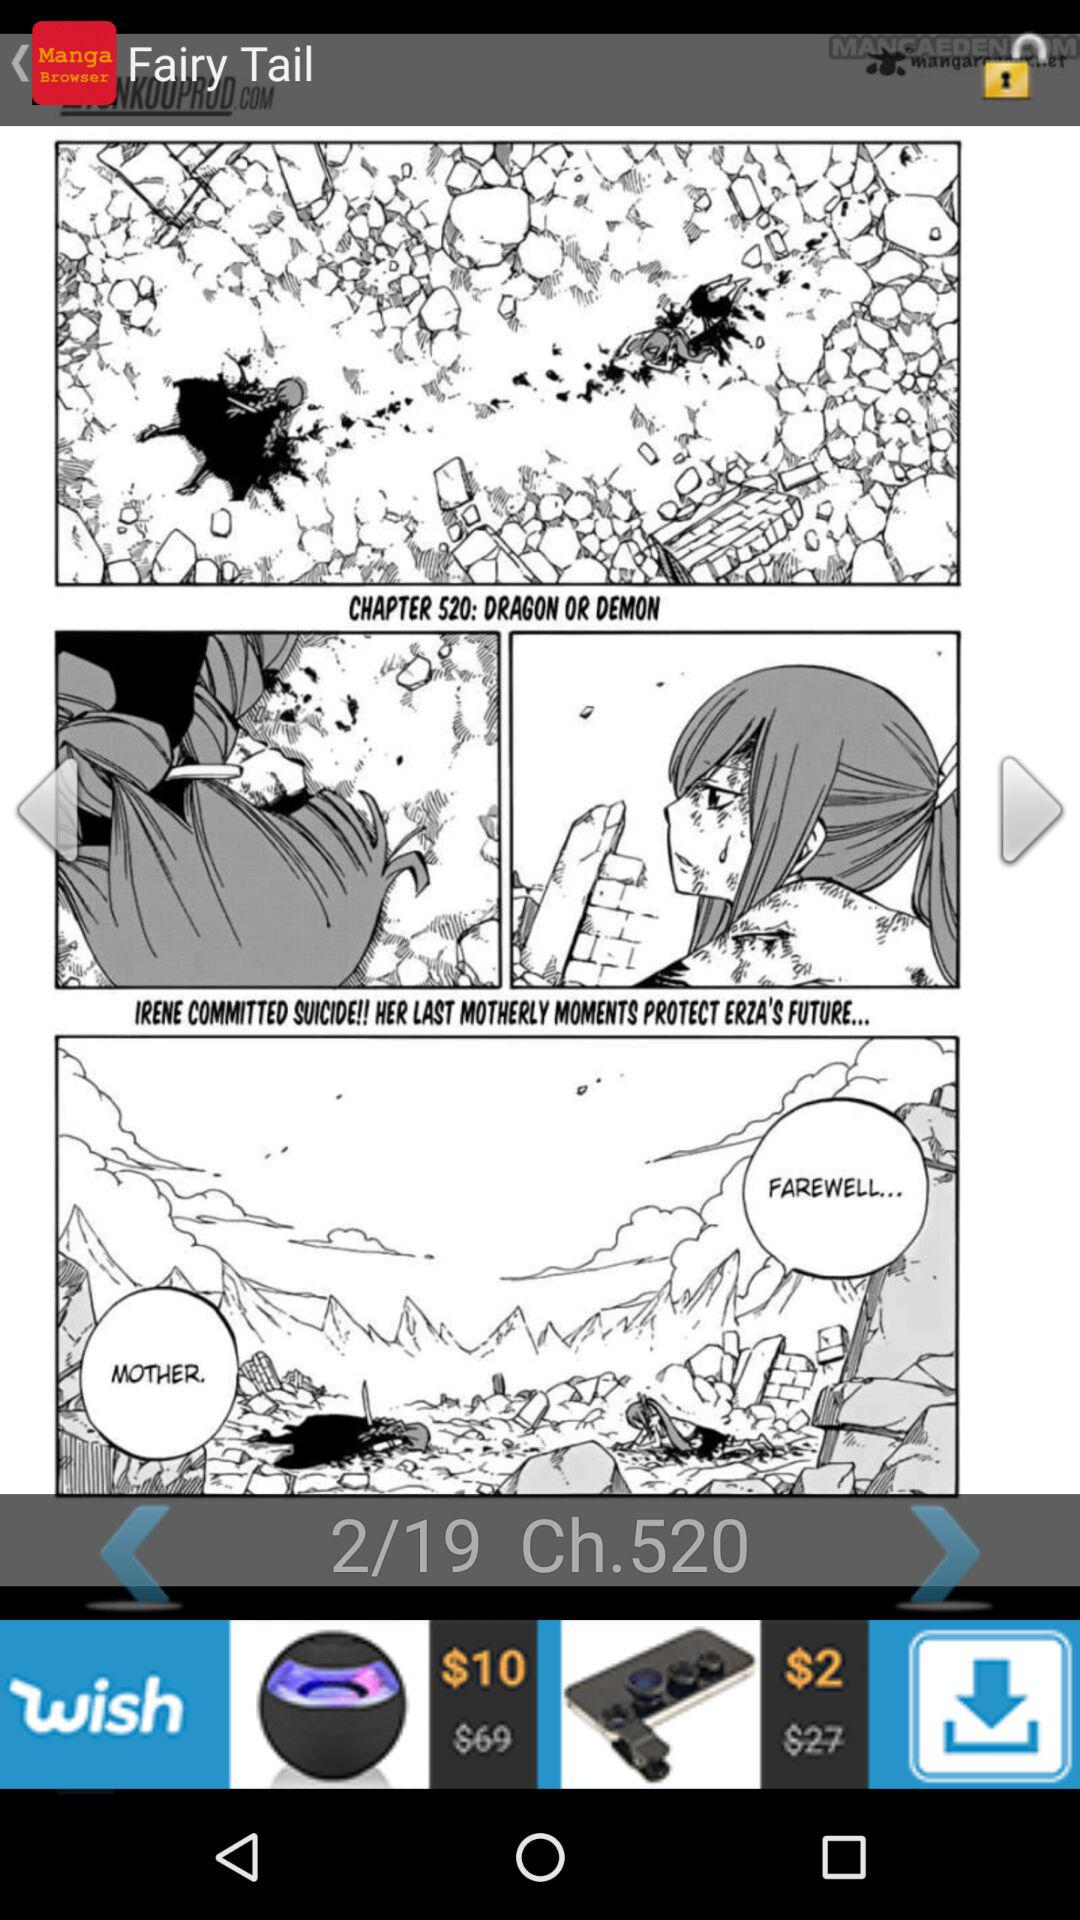Who is the artist?
When the provided information is insufficient, respond with <no answer>. <no answer> 